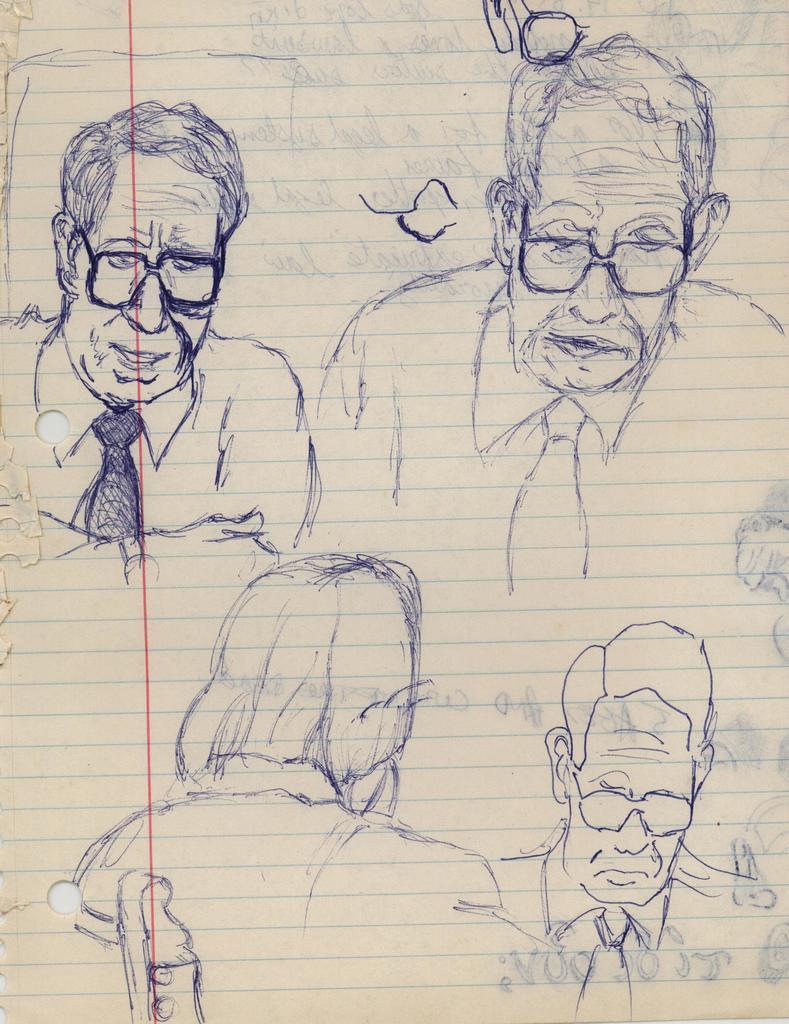How would you summarize this image in a sentence or two? In this image we can see a paper on which we can see a drawing of a few people. 